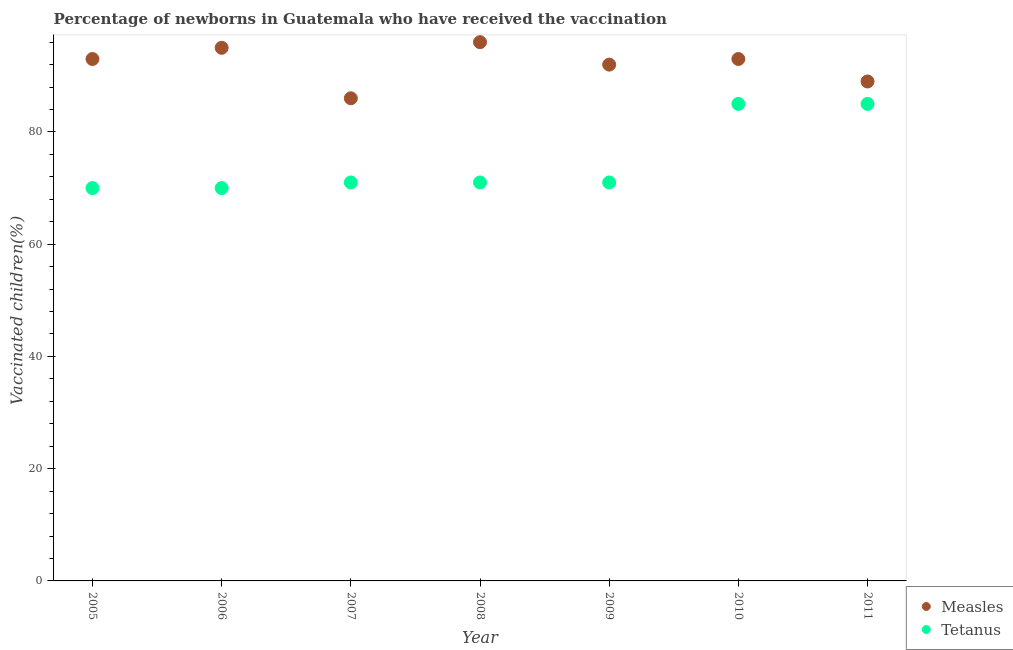What is the percentage of newborns who received vaccination for measles in 2007?
Your answer should be compact. 86. Across all years, what is the maximum percentage of newborns who received vaccination for measles?
Offer a terse response. 96. Across all years, what is the minimum percentage of newborns who received vaccination for measles?
Provide a short and direct response. 86. What is the total percentage of newborns who received vaccination for measles in the graph?
Give a very brief answer. 644. What is the difference between the percentage of newborns who received vaccination for measles in 2006 and that in 2010?
Provide a short and direct response. 2. What is the difference between the percentage of newborns who received vaccination for measles in 2006 and the percentage of newborns who received vaccination for tetanus in 2005?
Your answer should be very brief. 25. What is the average percentage of newborns who received vaccination for measles per year?
Offer a very short reply. 92. In the year 2011, what is the difference between the percentage of newborns who received vaccination for tetanus and percentage of newborns who received vaccination for measles?
Keep it short and to the point. -4. In how many years, is the percentage of newborns who received vaccination for tetanus greater than 20 %?
Keep it short and to the point. 7. What is the ratio of the percentage of newborns who received vaccination for measles in 2007 to that in 2009?
Your answer should be very brief. 0.93. Is the difference between the percentage of newborns who received vaccination for tetanus in 2006 and 2010 greater than the difference between the percentage of newborns who received vaccination for measles in 2006 and 2010?
Offer a terse response. No. What is the difference between the highest and the lowest percentage of newborns who received vaccination for tetanus?
Provide a short and direct response. 15. In how many years, is the percentage of newborns who received vaccination for measles greater than the average percentage of newborns who received vaccination for measles taken over all years?
Keep it short and to the point. 4. How many dotlines are there?
Your answer should be very brief. 2. How many years are there in the graph?
Make the answer very short. 7. What is the difference between two consecutive major ticks on the Y-axis?
Keep it short and to the point. 20. How many legend labels are there?
Provide a short and direct response. 2. What is the title of the graph?
Ensure brevity in your answer.  Percentage of newborns in Guatemala who have received the vaccination. Does "By country of origin" appear as one of the legend labels in the graph?
Make the answer very short. No. What is the label or title of the X-axis?
Provide a short and direct response. Year. What is the label or title of the Y-axis?
Give a very brief answer. Vaccinated children(%)
. What is the Vaccinated children(%)
 of Measles in 2005?
Ensure brevity in your answer.  93. What is the Vaccinated children(%)
 of Tetanus in 2005?
Your answer should be very brief. 70. What is the Vaccinated children(%)
 of Tetanus in 2006?
Offer a terse response. 70. What is the Vaccinated children(%)
 of Measles in 2007?
Your answer should be compact. 86. What is the Vaccinated children(%)
 in Measles in 2008?
Ensure brevity in your answer.  96. What is the Vaccinated children(%)
 of Measles in 2009?
Your answer should be very brief. 92. What is the Vaccinated children(%)
 in Measles in 2010?
Give a very brief answer. 93. What is the Vaccinated children(%)
 in Measles in 2011?
Offer a very short reply. 89. What is the Vaccinated children(%)
 of Tetanus in 2011?
Your response must be concise. 85. Across all years, what is the maximum Vaccinated children(%)
 in Measles?
Offer a very short reply. 96. Across all years, what is the minimum Vaccinated children(%)
 of Tetanus?
Give a very brief answer. 70. What is the total Vaccinated children(%)
 in Measles in the graph?
Your answer should be very brief. 644. What is the total Vaccinated children(%)
 of Tetanus in the graph?
Your answer should be compact. 523. What is the difference between the Vaccinated children(%)
 of Measles in 2005 and that in 2006?
Provide a short and direct response. -2. What is the difference between the Vaccinated children(%)
 in Tetanus in 2005 and that in 2006?
Offer a very short reply. 0. What is the difference between the Vaccinated children(%)
 of Measles in 2005 and that in 2008?
Provide a short and direct response. -3. What is the difference between the Vaccinated children(%)
 in Tetanus in 2005 and that in 2008?
Keep it short and to the point. -1. What is the difference between the Vaccinated children(%)
 of Measles in 2005 and that in 2009?
Your answer should be very brief. 1. What is the difference between the Vaccinated children(%)
 in Measles in 2005 and that in 2010?
Your response must be concise. 0. What is the difference between the Vaccinated children(%)
 in Tetanus in 2005 and that in 2010?
Your answer should be very brief. -15. What is the difference between the Vaccinated children(%)
 in Measles in 2005 and that in 2011?
Offer a very short reply. 4. What is the difference between the Vaccinated children(%)
 of Tetanus in 2006 and that in 2007?
Provide a succinct answer. -1. What is the difference between the Vaccinated children(%)
 of Tetanus in 2006 and that in 2008?
Make the answer very short. -1. What is the difference between the Vaccinated children(%)
 in Measles in 2006 and that in 2009?
Ensure brevity in your answer.  3. What is the difference between the Vaccinated children(%)
 in Tetanus in 2006 and that in 2009?
Your response must be concise. -1. What is the difference between the Vaccinated children(%)
 of Measles in 2006 and that in 2010?
Your answer should be very brief. 2. What is the difference between the Vaccinated children(%)
 of Measles in 2006 and that in 2011?
Give a very brief answer. 6. What is the difference between the Vaccinated children(%)
 of Tetanus in 2006 and that in 2011?
Your answer should be very brief. -15. What is the difference between the Vaccinated children(%)
 of Measles in 2007 and that in 2008?
Your response must be concise. -10. What is the difference between the Vaccinated children(%)
 of Tetanus in 2007 and that in 2008?
Provide a succinct answer. 0. What is the difference between the Vaccinated children(%)
 of Measles in 2007 and that in 2009?
Ensure brevity in your answer.  -6. What is the difference between the Vaccinated children(%)
 in Measles in 2007 and that in 2010?
Offer a terse response. -7. What is the difference between the Vaccinated children(%)
 in Tetanus in 2007 and that in 2010?
Your response must be concise. -14. What is the difference between the Vaccinated children(%)
 in Measles in 2008 and that in 2009?
Your answer should be very brief. 4. What is the difference between the Vaccinated children(%)
 in Measles in 2008 and that in 2010?
Your answer should be compact. 3. What is the difference between the Vaccinated children(%)
 of Measles in 2008 and that in 2011?
Ensure brevity in your answer.  7. What is the difference between the Vaccinated children(%)
 of Tetanus in 2008 and that in 2011?
Give a very brief answer. -14. What is the difference between the Vaccinated children(%)
 in Tetanus in 2009 and that in 2010?
Give a very brief answer. -14. What is the difference between the Vaccinated children(%)
 of Measles in 2009 and that in 2011?
Your response must be concise. 3. What is the difference between the Vaccinated children(%)
 in Measles in 2005 and the Vaccinated children(%)
 in Tetanus in 2006?
Keep it short and to the point. 23. What is the difference between the Vaccinated children(%)
 in Measles in 2005 and the Vaccinated children(%)
 in Tetanus in 2008?
Ensure brevity in your answer.  22. What is the difference between the Vaccinated children(%)
 in Measles in 2005 and the Vaccinated children(%)
 in Tetanus in 2010?
Make the answer very short. 8. What is the difference between the Vaccinated children(%)
 in Measles in 2006 and the Vaccinated children(%)
 in Tetanus in 2008?
Keep it short and to the point. 24. What is the difference between the Vaccinated children(%)
 in Measles in 2006 and the Vaccinated children(%)
 in Tetanus in 2009?
Offer a terse response. 24. What is the difference between the Vaccinated children(%)
 in Measles in 2007 and the Vaccinated children(%)
 in Tetanus in 2011?
Ensure brevity in your answer.  1. What is the difference between the Vaccinated children(%)
 in Measles in 2008 and the Vaccinated children(%)
 in Tetanus in 2010?
Your answer should be very brief. 11. What is the difference between the Vaccinated children(%)
 in Measles in 2009 and the Vaccinated children(%)
 in Tetanus in 2011?
Offer a very short reply. 7. What is the average Vaccinated children(%)
 in Measles per year?
Provide a short and direct response. 92. What is the average Vaccinated children(%)
 in Tetanus per year?
Make the answer very short. 74.71. In the year 2005, what is the difference between the Vaccinated children(%)
 of Measles and Vaccinated children(%)
 of Tetanus?
Your response must be concise. 23. In the year 2006, what is the difference between the Vaccinated children(%)
 in Measles and Vaccinated children(%)
 in Tetanus?
Provide a succinct answer. 25. In the year 2009, what is the difference between the Vaccinated children(%)
 in Measles and Vaccinated children(%)
 in Tetanus?
Your response must be concise. 21. In the year 2011, what is the difference between the Vaccinated children(%)
 of Measles and Vaccinated children(%)
 of Tetanus?
Offer a very short reply. 4. What is the ratio of the Vaccinated children(%)
 of Measles in 2005 to that in 2006?
Offer a very short reply. 0.98. What is the ratio of the Vaccinated children(%)
 of Measles in 2005 to that in 2007?
Offer a terse response. 1.08. What is the ratio of the Vaccinated children(%)
 in Tetanus in 2005 to that in 2007?
Offer a very short reply. 0.99. What is the ratio of the Vaccinated children(%)
 of Measles in 2005 to that in 2008?
Provide a short and direct response. 0.97. What is the ratio of the Vaccinated children(%)
 of Tetanus in 2005 to that in 2008?
Your response must be concise. 0.99. What is the ratio of the Vaccinated children(%)
 of Measles in 2005 to that in 2009?
Provide a succinct answer. 1.01. What is the ratio of the Vaccinated children(%)
 in Tetanus in 2005 to that in 2009?
Provide a short and direct response. 0.99. What is the ratio of the Vaccinated children(%)
 of Measles in 2005 to that in 2010?
Your answer should be very brief. 1. What is the ratio of the Vaccinated children(%)
 in Tetanus in 2005 to that in 2010?
Offer a terse response. 0.82. What is the ratio of the Vaccinated children(%)
 of Measles in 2005 to that in 2011?
Offer a very short reply. 1.04. What is the ratio of the Vaccinated children(%)
 of Tetanus in 2005 to that in 2011?
Your response must be concise. 0.82. What is the ratio of the Vaccinated children(%)
 in Measles in 2006 to that in 2007?
Give a very brief answer. 1.1. What is the ratio of the Vaccinated children(%)
 of Tetanus in 2006 to that in 2007?
Provide a short and direct response. 0.99. What is the ratio of the Vaccinated children(%)
 of Measles in 2006 to that in 2008?
Ensure brevity in your answer.  0.99. What is the ratio of the Vaccinated children(%)
 of Tetanus in 2006 to that in 2008?
Give a very brief answer. 0.99. What is the ratio of the Vaccinated children(%)
 of Measles in 2006 to that in 2009?
Make the answer very short. 1.03. What is the ratio of the Vaccinated children(%)
 in Tetanus in 2006 to that in 2009?
Keep it short and to the point. 0.99. What is the ratio of the Vaccinated children(%)
 of Measles in 2006 to that in 2010?
Provide a succinct answer. 1.02. What is the ratio of the Vaccinated children(%)
 of Tetanus in 2006 to that in 2010?
Offer a terse response. 0.82. What is the ratio of the Vaccinated children(%)
 in Measles in 2006 to that in 2011?
Offer a terse response. 1.07. What is the ratio of the Vaccinated children(%)
 of Tetanus in 2006 to that in 2011?
Ensure brevity in your answer.  0.82. What is the ratio of the Vaccinated children(%)
 in Measles in 2007 to that in 2008?
Provide a short and direct response. 0.9. What is the ratio of the Vaccinated children(%)
 of Tetanus in 2007 to that in 2008?
Provide a short and direct response. 1. What is the ratio of the Vaccinated children(%)
 in Measles in 2007 to that in 2009?
Your response must be concise. 0.93. What is the ratio of the Vaccinated children(%)
 of Tetanus in 2007 to that in 2009?
Your response must be concise. 1. What is the ratio of the Vaccinated children(%)
 of Measles in 2007 to that in 2010?
Ensure brevity in your answer.  0.92. What is the ratio of the Vaccinated children(%)
 of Tetanus in 2007 to that in 2010?
Your answer should be very brief. 0.84. What is the ratio of the Vaccinated children(%)
 of Measles in 2007 to that in 2011?
Provide a short and direct response. 0.97. What is the ratio of the Vaccinated children(%)
 of Tetanus in 2007 to that in 2011?
Give a very brief answer. 0.84. What is the ratio of the Vaccinated children(%)
 in Measles in 2008 to that in 2009?
Offer a very short reply. 1.04. What is the ratio of the Vaccinated children(%)
 in Tetanus in 2008 to that in 2009?
Give a very brief answer. 1. What is the ratio of the Vaccinated children(%)
 of Measles in 2008 to that in 2010?
Provide a succinct answer. 1.03. What is the ratio of the Vaccinated children(%)
 of Tetanus in 2008 to that in 2010?
Provide a succinct answer. 0.84. What is the ratio of the Vaccinated children(%)
 of Measles in 2008 to that in 2011?
Your answer should be compact. 1.08. What is the ratio of the Vaccinated children(%)
 of Tetanus in 2008 to that in 2011?
Provide a succinct answer. 0.84. What is the ratio of the Vaccinated children(%)
 of Measles in 2009 to that in 2010?
Make the answer very short. 0.99. What is the ratio of the Vaccinated children(%)
 in Tetanus in 2009 to that in 2010?
Your answer should be compact. 0.84. What is the ratio of the Vaccinated children(%)
 of Measles in 2009 to that in 2011?
Your answer should be compact. 1.03. What is the ratio of the Vaccinated children(%)
 in Tetanus in 2009 to that in 2011?
Your answer should be very brief. 0.84. What is the ratio of the Vaccinated children(%)
 in Measles in 2010 to that in 2011?
Your answer should be compact. 1.04. What is the difference between the highest and the second highest Vaccinated children(%)
 in Tetanus?
Give a very brief answer. 0. What is the difference between the highest and the lowest Vaccinated children(%)
 of Tetanus?
Ensure brevity in your answer.  15. 